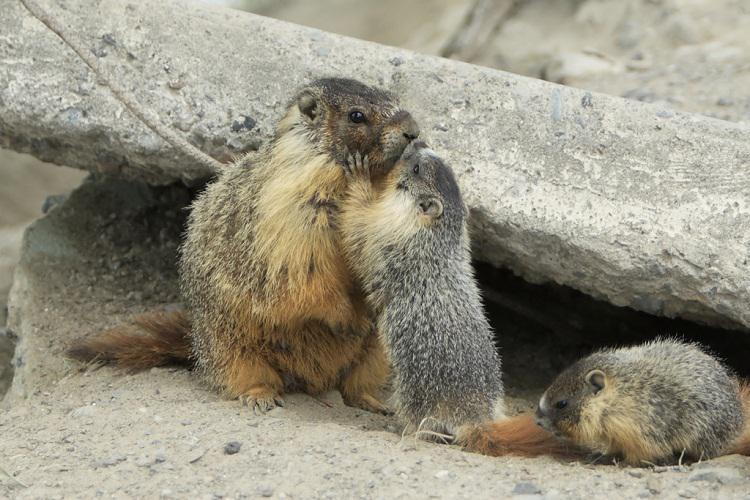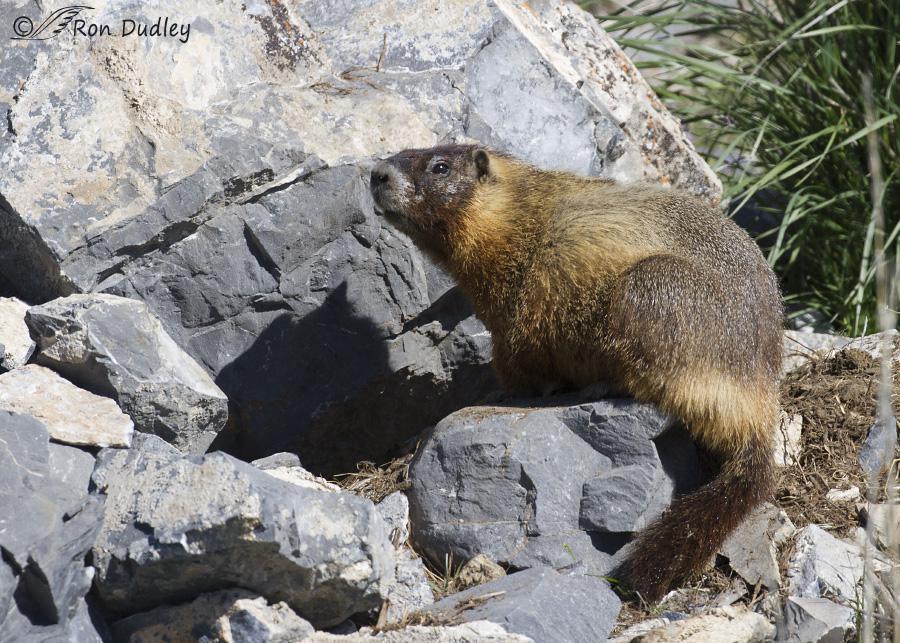The first image is the image on the left, the second image is the image on the right. Evaluate the accuracy of this statement regarding the images: "There are three animals near the rocks.". Is it true? Answer yes or no. Yes. 